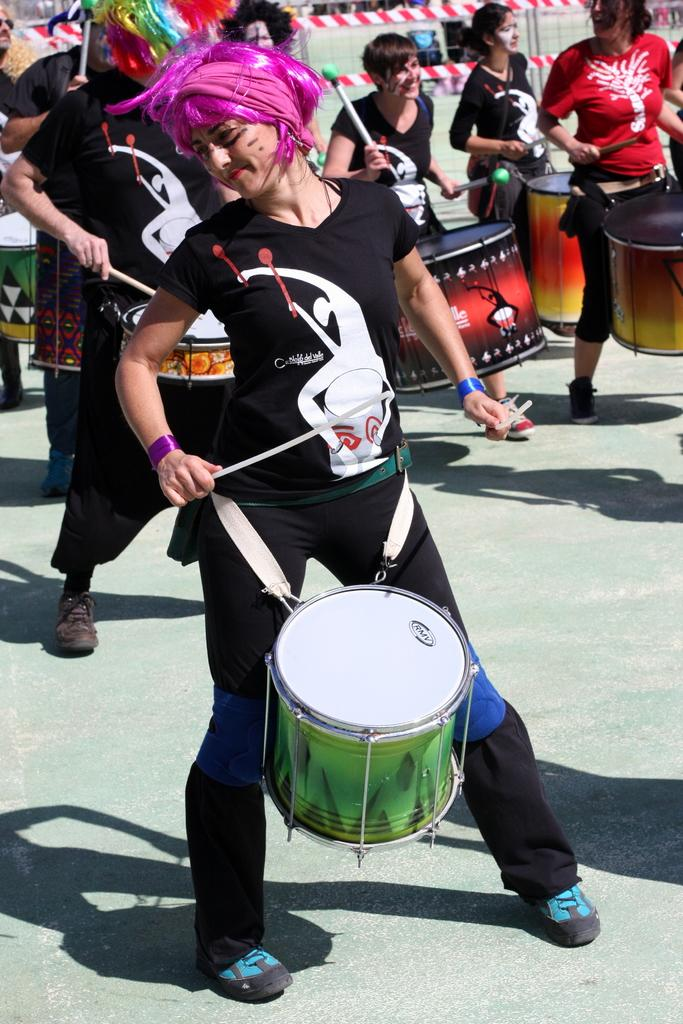Who or what is present in the image? There are people in the image. What are the people doing in the image? The people are playing drums. What can be seen in the background of the image? There is a fencing visible behind the people. Can you hear the people in the image laughing while playing the drums? There is no sound in the image, so it is not possible to determine if the people are laughing or not. 